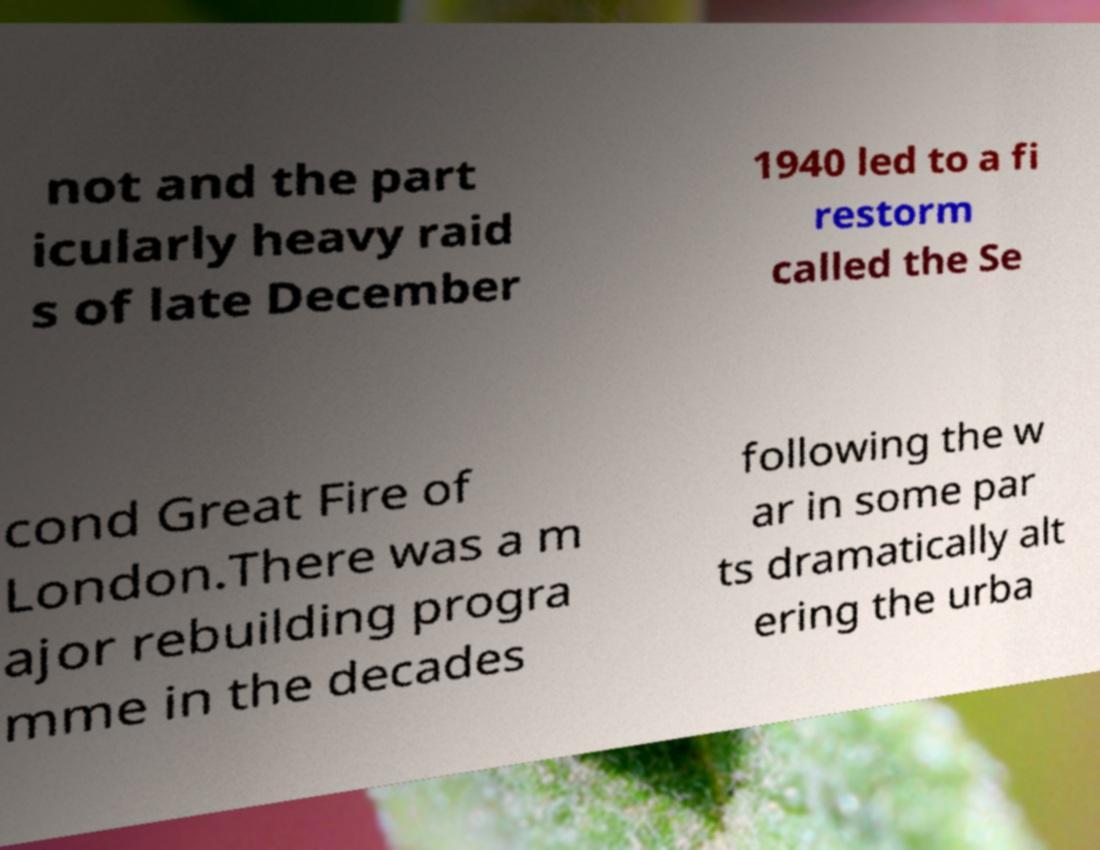Please read and relay the text visible in this image. What does it say? not and the part icularly heavy raid s of late December 1940 led to a fi restorm called the Se cond Great Fire of London.There was a m ajor rebuilding progra mme in the decades following the w ar in some par ts dramatically alt ering the urba 